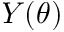<formula> <loc_0><loc_0><loc_500><loc_500>Y ( \theta )</formula> 